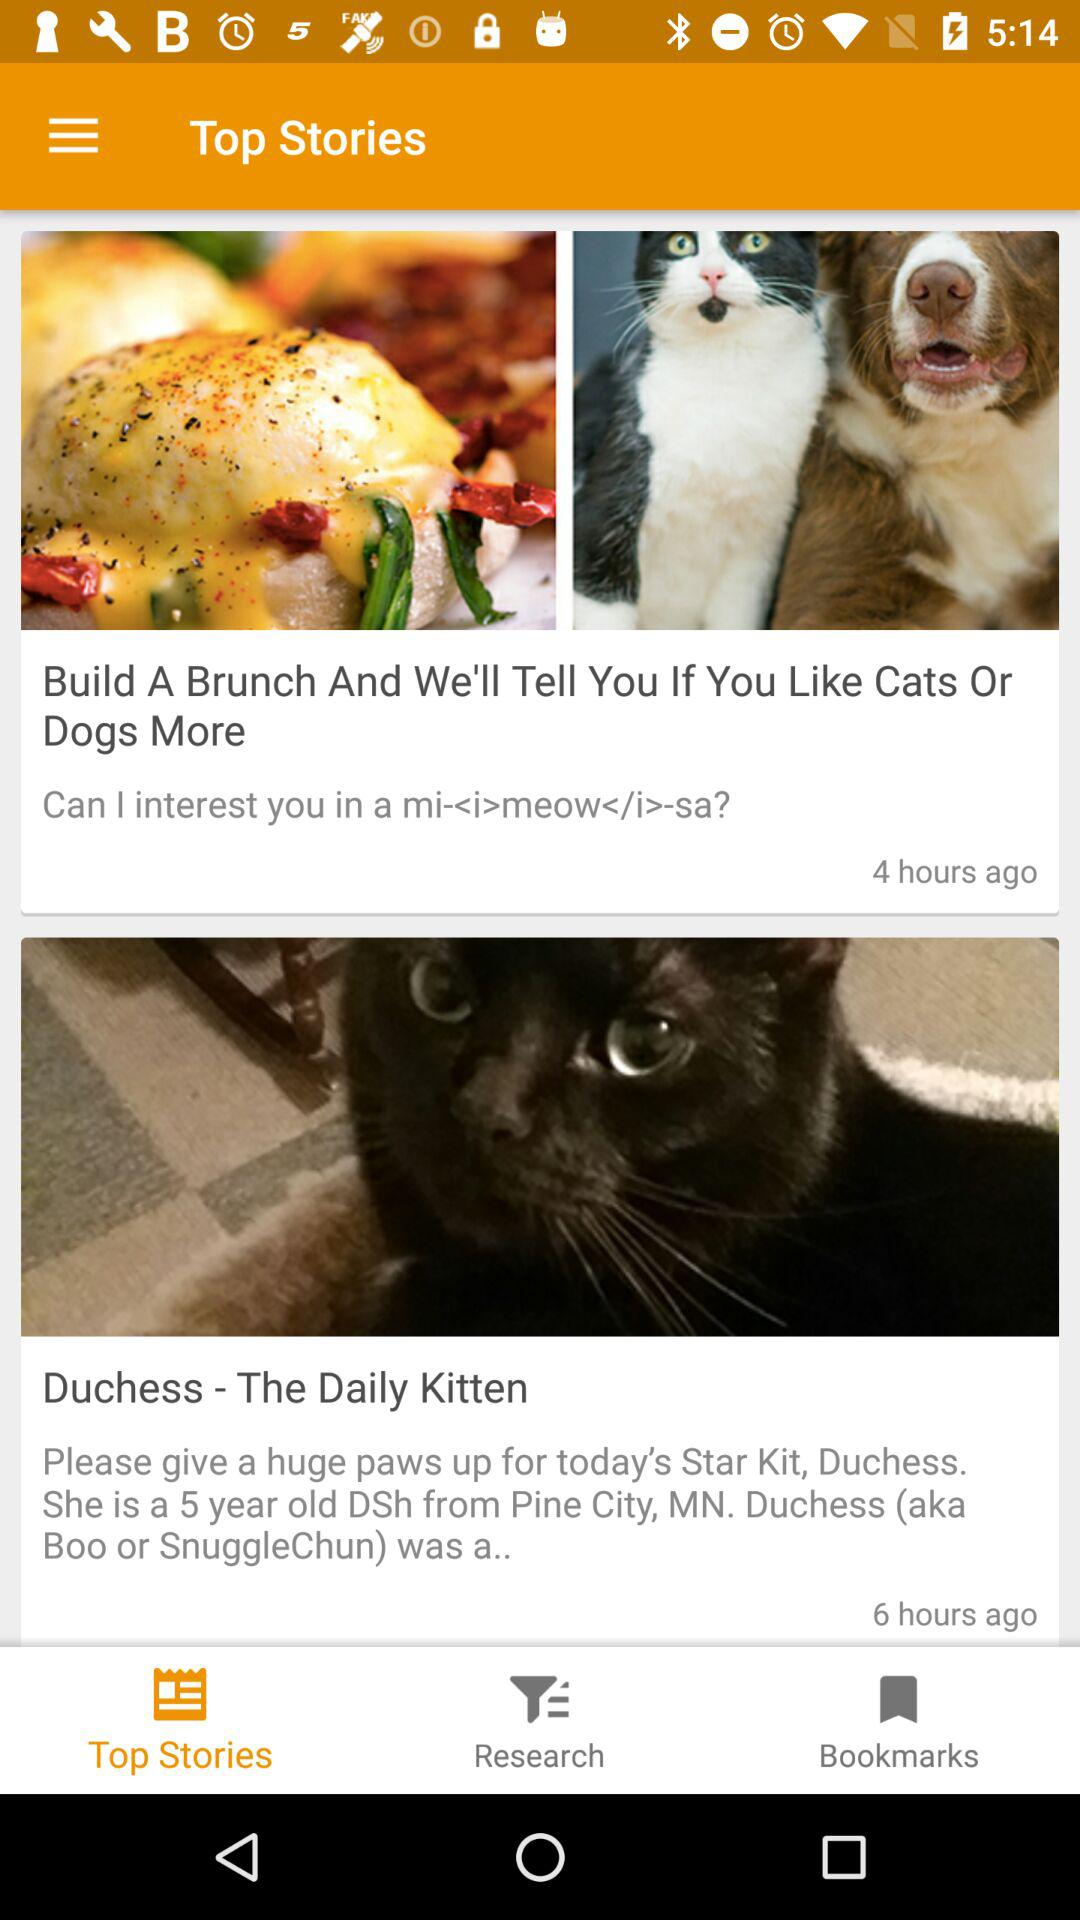How many hours ago was the first article published?
Answer the question using a single word or phrase. 4 